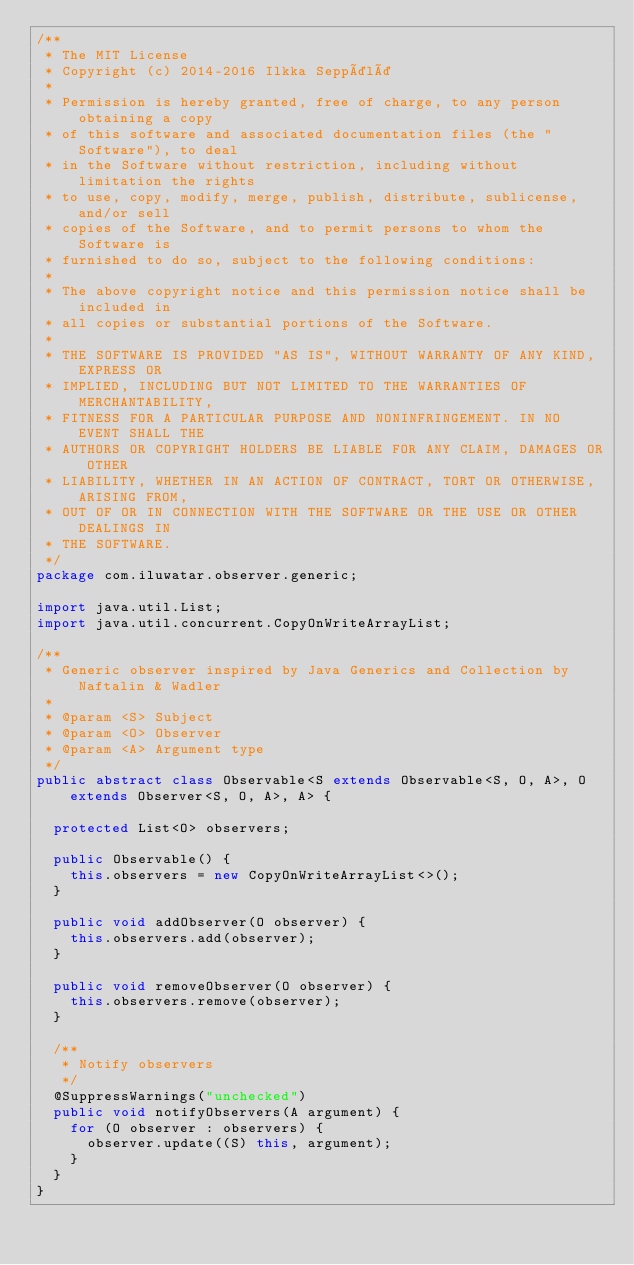Convert code to text. <code><loc_0><loc_0><loc_500><loc_500><_Java_>/**
 * The MIT License
 * Copyright (c) 2014-2016 Ilkka Seppälä
 *
 * Permission is hereby granted, free of charge, to any person obtaining a copy
 * of this software and associated documentation files (the "Software"), to deal
 * in the Software without restriction, including without limitation the rights
 * to use, copy, modify, merge, publish, distribute, sublicense, and/or sell
 * copies of the Software, and to permit persons to whom the Software is
 * furnished to do so, subject to the following conditions:
 *
 * The above copyright notice and this permission notice shall be included in
 * all copies or substantial portions of the Software.
 *
 * THE SOFTWARE IS PROVIDED "AS IS", WITHOUT WARRANTY OF ANY KIND, EXPRESS OR
 * IMPLIED, INCLUDING BUT NOT LIMITED TO THE WARRANTIES OF MERCHANTABILITY,
 * FITNESS FOR A PARTICULAR PURPOSE AND NONINFRINGEMENT. IN NO EVENT SHALL THE
 * AUTHORS OR COPYRIGHT HOLDERS BE LIABLE FOR ANY CLAIM, DAMAGES OR OTHER
 * LIABILITY, WHETHER IN AN ACTION OF CONTRACT, TORT OR OTHERWISE, ARISING FROM,
 * OUT OF OR IN CONNECTION WITH THE SOFTWARE OR THE USE OR OTHER DEALINGS IN
 * THE SOFTWARE.
 */
package com.iluwatar.observer.generic;

import java.util.List;
import java.util.concurrent.CopyOnWriteArrayList;

/**
 * Generic observer inspired by Java Generics and Collection by Naftalin & Wadler
 *
 * @param <S> Subject
 * @param <O> Observer
 * @param <A> Argument type
 */
public abstract class Observable<S extends Observable<S, O, A>, O extends Observer<S, O, A>, A> {

  protected List<O> observers;

  public Observable() {
    this.observers = new CopyOnWriteArrayList<>();
  }

  public void addObserver(O observer) {
    this.observers.add(observer);
  }

  public void removeObserver(O observer) {
    this.observers.remove(observer);
  }

  /**
   * Notify observers
   */
  @SuppressWarnings("unchecked")
  public void notifyObservers(A argument) {
    for (O observer : observers) {
      observer.update((S) this, argument);
    }
  }
}
</code> 